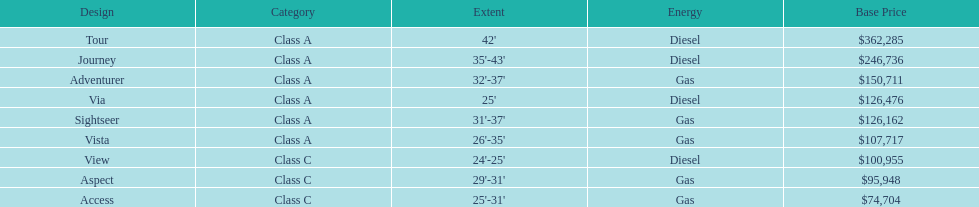What is the name of the top priced winnebago model? Tour. 